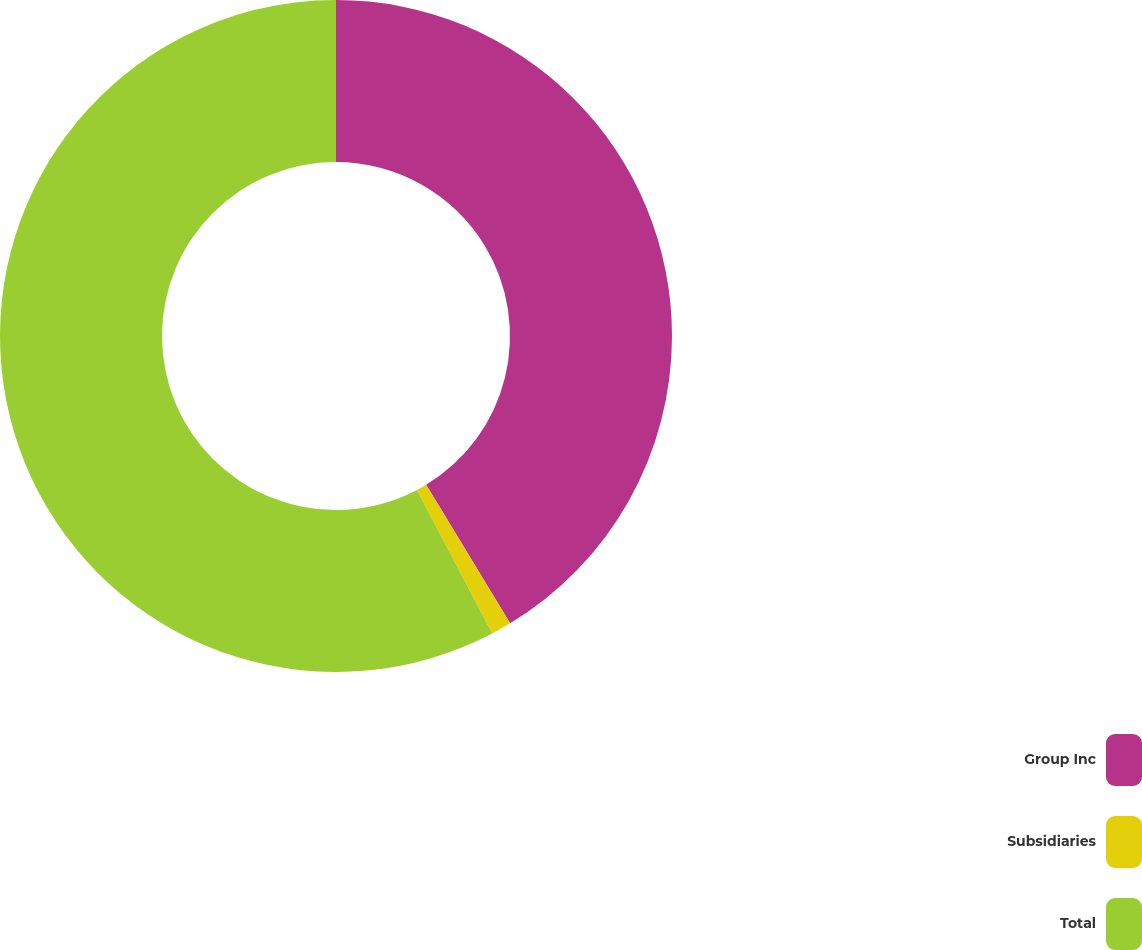Convert chart to OTSL. <chart><loc_0><loc_0><loc_500><loc_500><pie_chart><fcel>Group Inc<fcel>Subsidiaries<fcel>Total<nl><fcel>41.33%<fcel>0.97%<fcel>57.7%<nl></chart> 